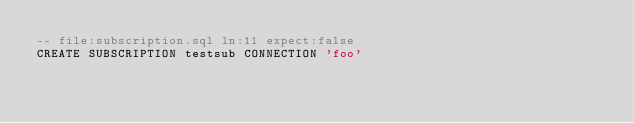Convert code to text. <code><loc_0><loc_0><loc_500><loc_500><_SQL_>-- file:subscription.sql ln:11 expect:false
CREATE SUBSCRIPTION testsub CONNECTION 'foo'
</code> 